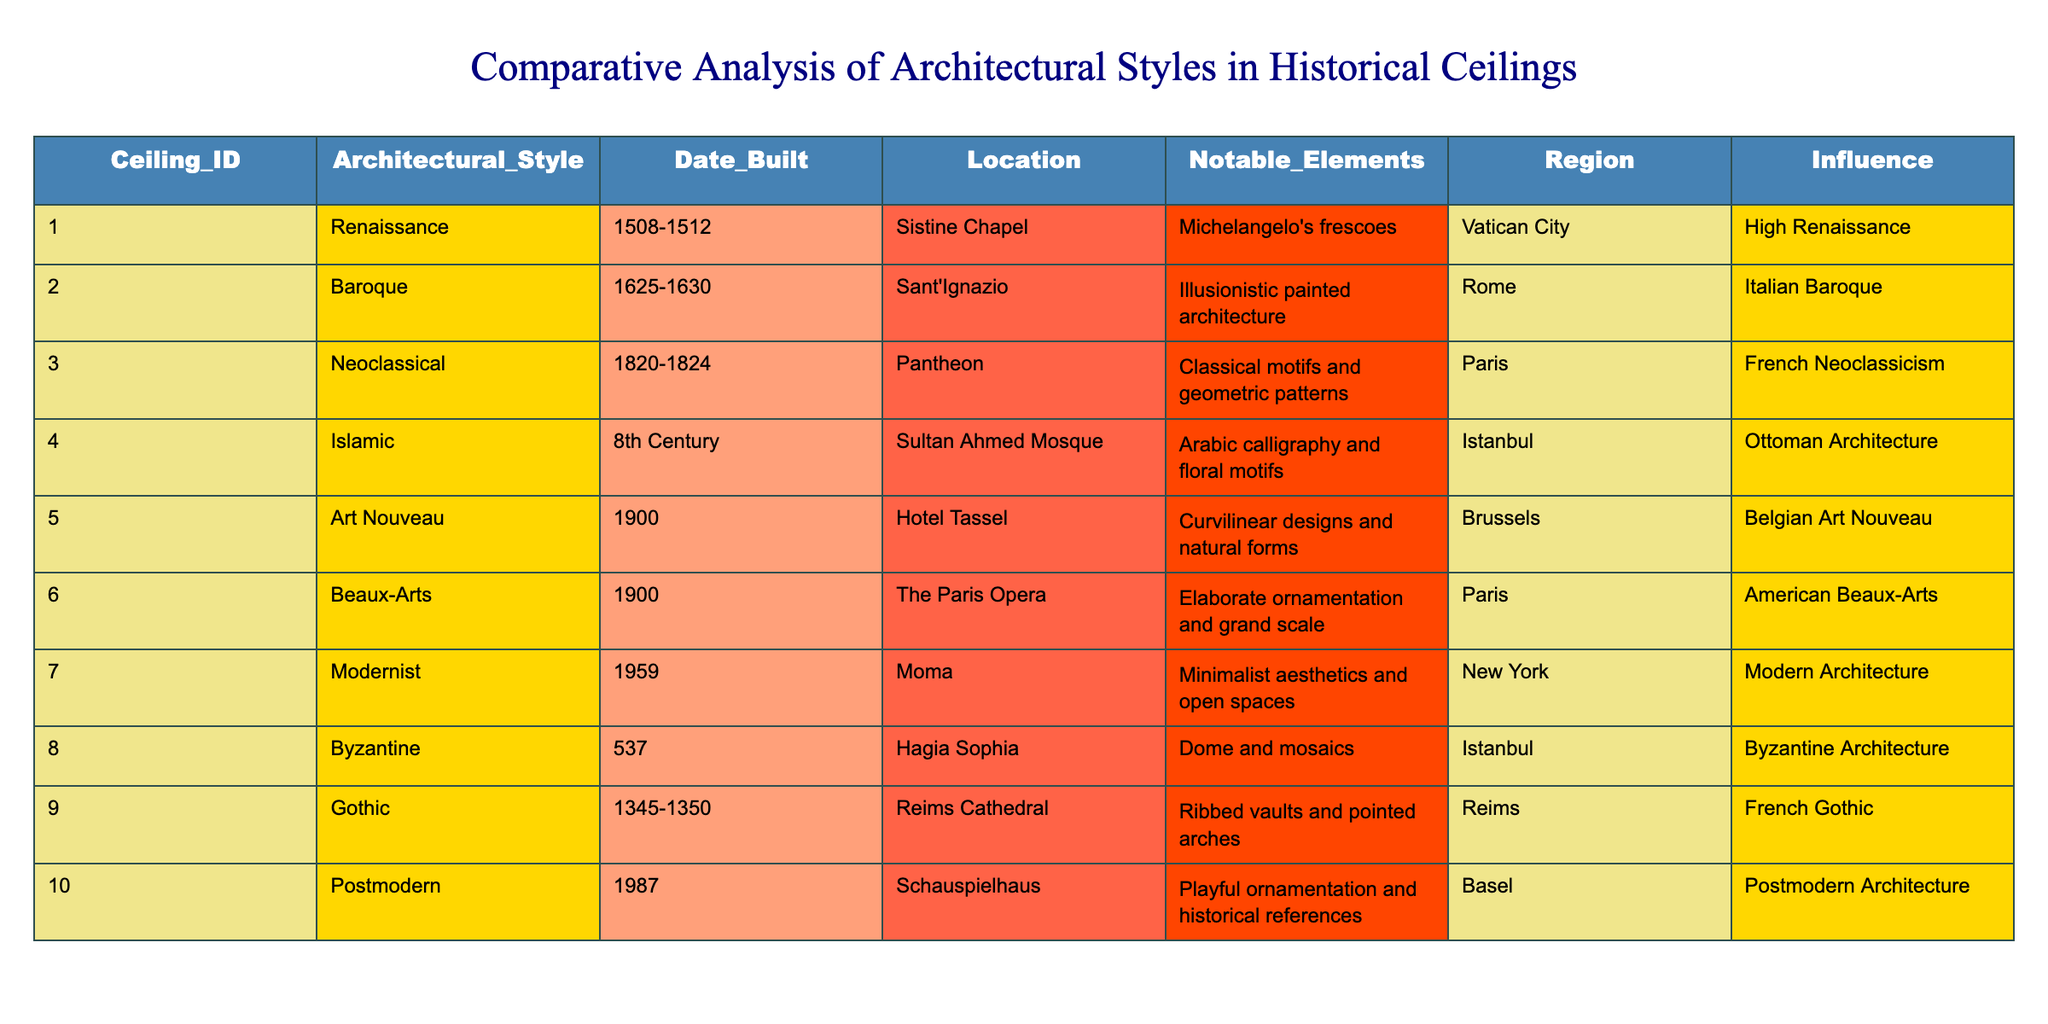What architectural style is associated with the Sistine Chapel? The table lists the architectural style for the Sistine Chapel under the "Architectural_Style" column, which is "Renaissance".
Answer: Renaissance Which ceiling was built in the 8th Century? In the "Date_Built" column, the entry for the Sultan Ahmed Mosque indicates "8th Century" as its built date.
Answer: Sultan Ahmed Mosque What notable elements are found in the Pantheon ceiling? Looking at the "Notable_Elements" column for the Pantheon, it states "Classical motifs and geometric patterns".
Answer: Classical motifs and geometric patterns How many ceilings listed are from the 20th century? From the table, there are 3 entries that have been built in the 20th century: Hotel Tassel (1900), The Paris Opera (1900), and Schauspielhaus (1987). Thus, there are 3 ceilings total.
Answer: 3 Which two regions showcase Islamic ceilings? Referring to the "Region" column, the two Islamic ceilings listed are from Istanbul: the Sultan Ahmed Mosque and the Hagia Sophia.
Answer: Istanbul Is it true that the Reims Cathedral features ribbed vaults? The table states that the notable elements of the Reims Cathedral include "Ribbed vaults and pointed arches", confirming that the statement is true.
Answer: True What is the difference in the date built between the Byzantine and Gothic ceilings? The Byzantine ceiling (Hagia Sophia) was built in 537, while the Gothic ceiling (Reims Cathedral) was built between 1345 and 1350. The difference in years is approximately 808 to 813 years, depending on the specific year considered within the Gothic range, which is substantial.
Answer: Approximately 808 to 813 years Which architectural style has the most recent ceiling in the table? By examining the "Date_Built" column, the most recent ceiling is from the Postmodern style, built in 1987 for the Schauspielhaus.
Answer: Postmodern What notable elements differentiate Baroque from Neoclassical ceilings? The Baroque ceiling (Sant'Ignazio) features "Illusionistic painted architecture", while the Neoclassical ceiling (Pantheon) has "Classical motifs and geometric patterns". This indicates a clear distinction in design and thematic approach.
Answer: Illusionistic painted architecture vs. Classical motifs If we consider the influences listed, which architectural style is associated with Ottoman Architecture? Referring to the "Influence" column, the Islamic ceiling (Sultan Ahmed Mosque) is described as being influenced by "Ottoman Architecture".
Answer: Ottoman Architecture 